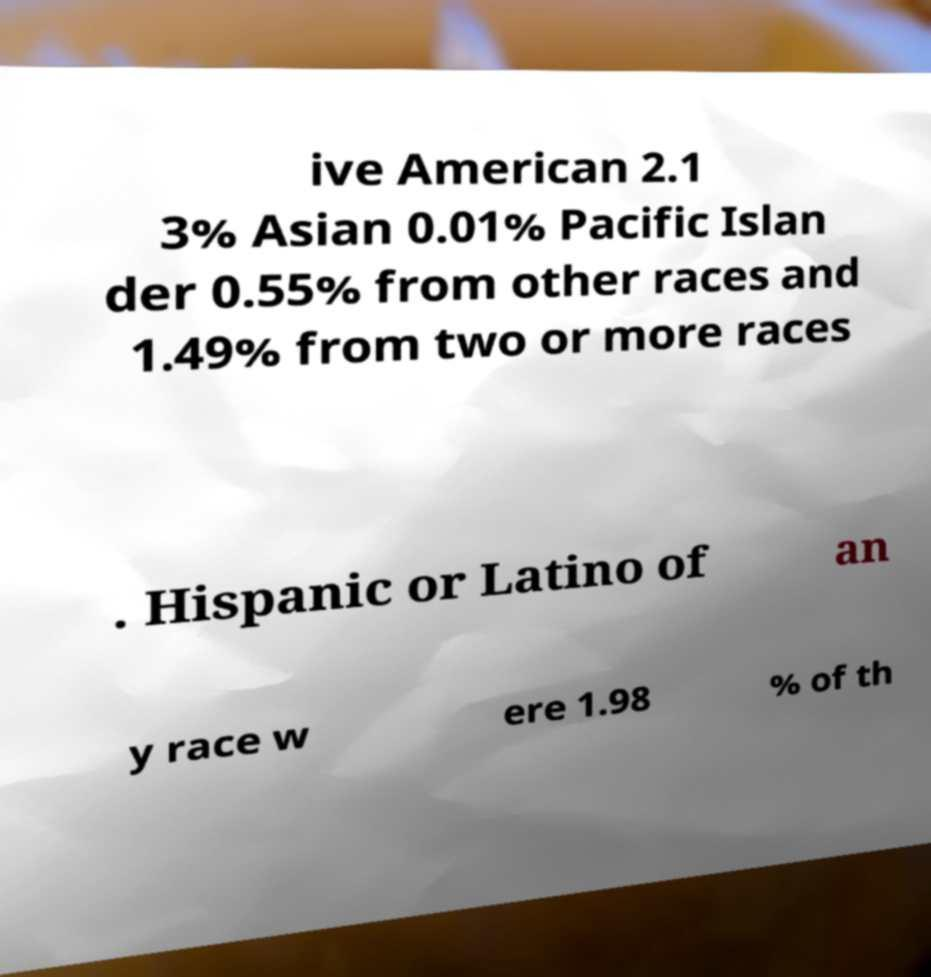Please read and relay the text visible in this image. What does it say? ive American 2.1 3% Asian 0.01% Pacific Islan der 0.55% from other races and 1.49% from two or more races . Hispanic or Latino of an y race w ere 1.98 % of th 